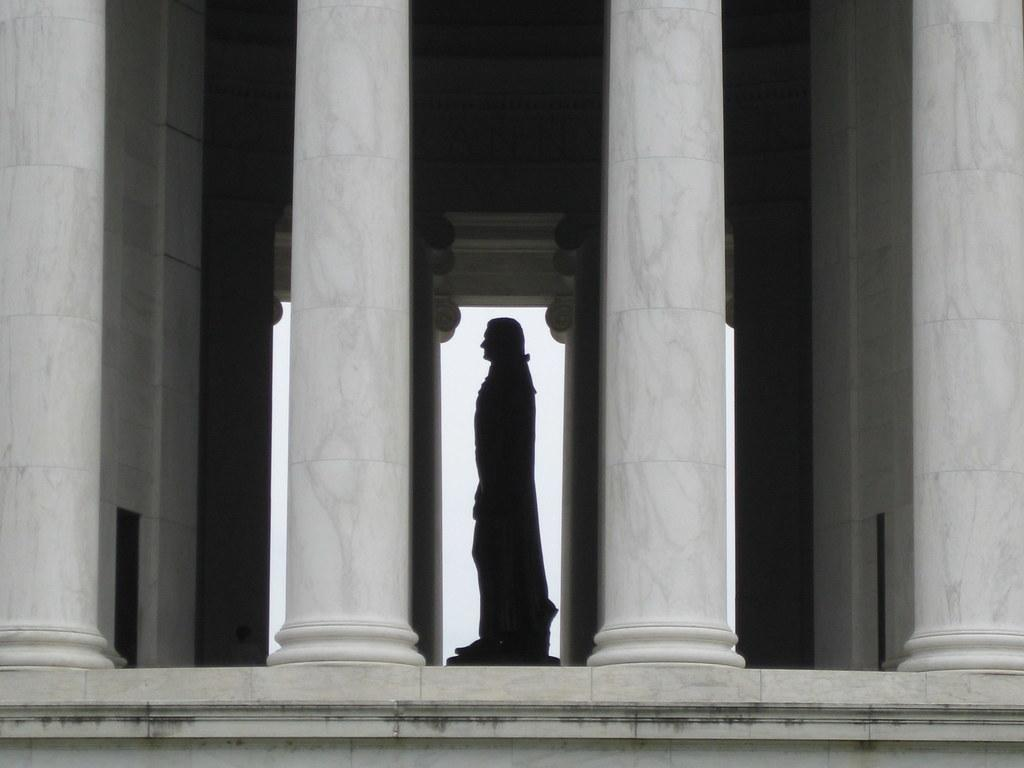How many pillars are present in the image? There are four white color pillars in the image. What can be seen in the background of the image? There is a statue in the background of the image. What surrounds the pillars in the image? There are walls on the sides of the image. What type of flower is growing on top of the pillars in the image? There are no flowers present on top of the pillars in the image. 